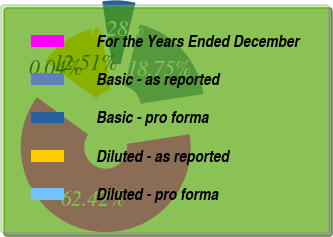Convert chart. <chart><loc_0><loc_0><loc_500><loc_500><pie_chart><fcel>For the Years Ended December<fcel>Basic - as reported<fcel>Basic - pro forma<fcel>Diluted - as reported<fcel>Diluted - pro forma<nl><fcel>62.42%<fcel>18.75%<fcel>6.28%<fcel>12.51%<fcel>0.04%<nl></chart> 